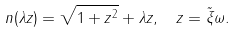Convert formula to latex. <formula><loc_0><loc_0><loc_500><loc_500>n ( \lambda z ) = \sqrt { 1 + z ^ { 2 } } + \lambda z , \, \ z = \tilde { \xi } \omega .</formula> 